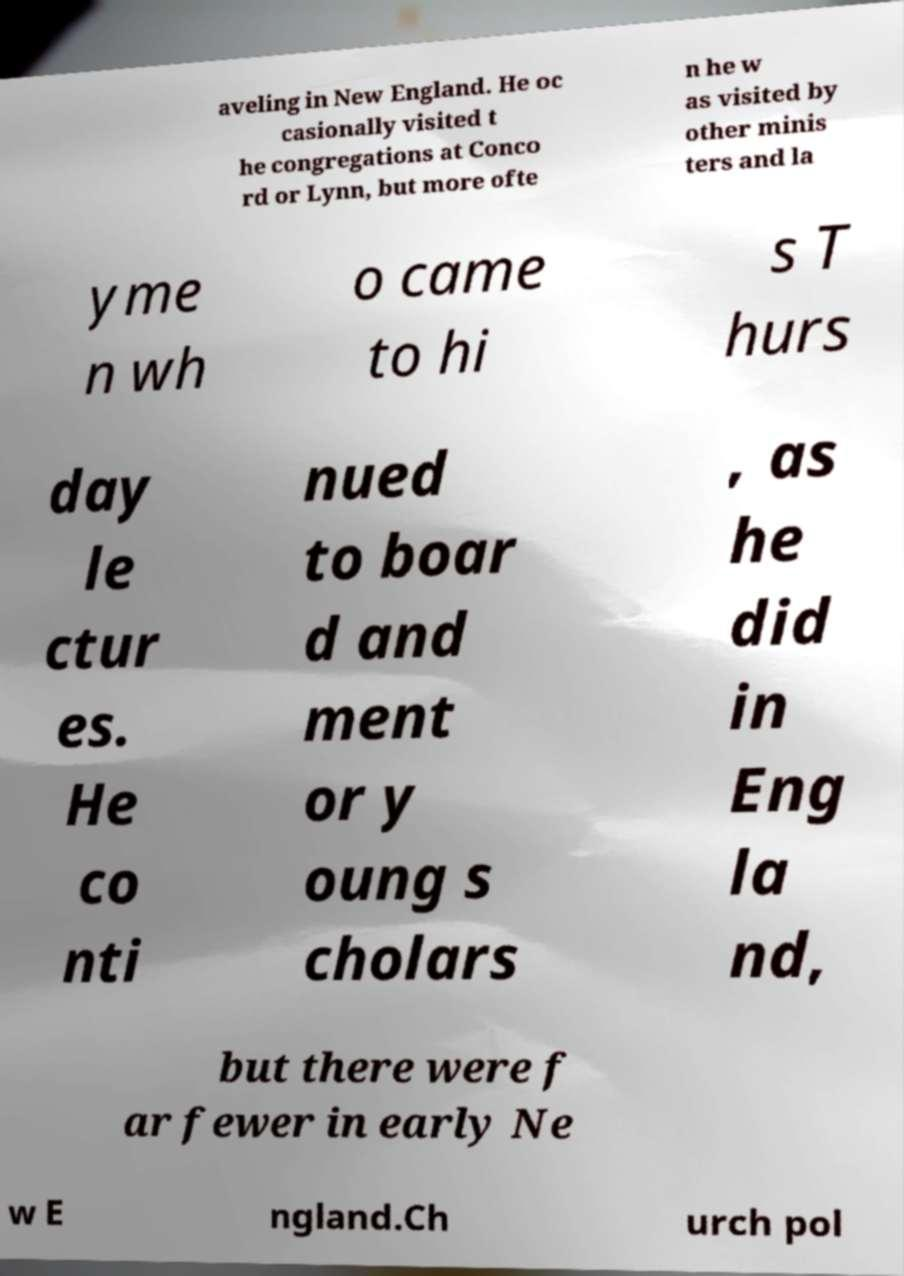For documentation purposes, I need the text within this image transcribed. Could you provide that? aveling in New England. He oc casionally visited t he congregations at Conco rd or Lynn, but more ofte n he w as visited by other minis ters and la yme n wh o came to hi s T hurs day le ctur es. He co nti nued to boar d and ment or y oung s cholars , as he did in Eng la nd, but there were f ar fewer in early Ne w E ngland.Ch urch pol 